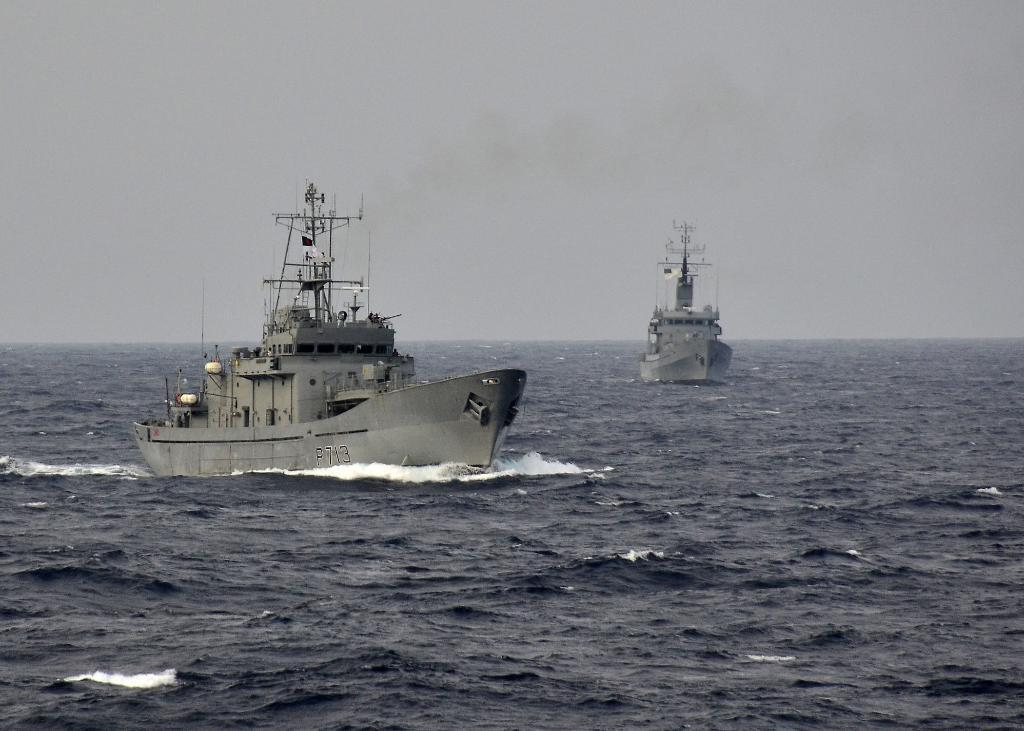How many boats can be seen in the image? There are two boats in the image. Where are the boats located in the image? The boats are in the water. What is visible in the sky in the image? The sky is visible in the image. What type of water body might the image be taken in? The image is likely taken in the ocean. How many ducks are swimming in the water near the boats in the image? There are no ducks visible in the image; it only features two boats in the water. What type of office equipment can be seen in the image? There is no office equipment present in the image. 